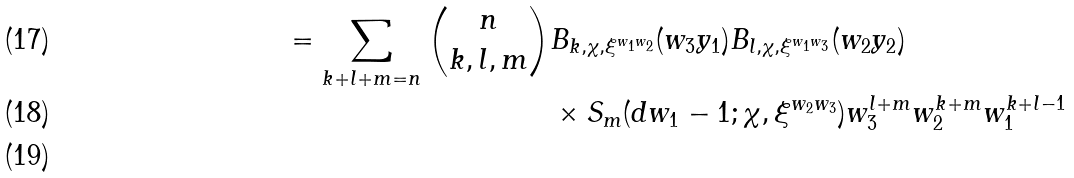Convert formula to latex. <formula><loc_0><loc_0><loc_500><loc_500>= \sum _ { k + l + m = n } \binom { n } { k , l , m } & B _ { k , \chi , \xi ^ { w _ { 1 } w _ { 2 } } } ( w _ { 3 } y _ { 1 } ) B _ { l , \chi , \xi ^ { w _ { 1 } w _ { 3 } } } ( w _ { 2 } y _ { 2 } ) \\ & \times S _ { m } ( d w _ { 1 } - 1 ; \chi , \xi ^ { w _ { 2 } w _ { 3 } } ) w _ { 3 } ^ { l + m } w _ { 2 } ^ { k + m } w _ { 1 } ^ { k + l - 1 } \\</formula> 